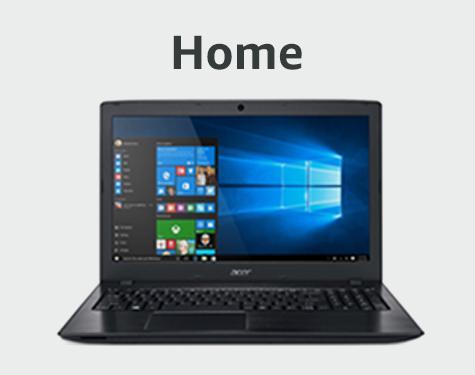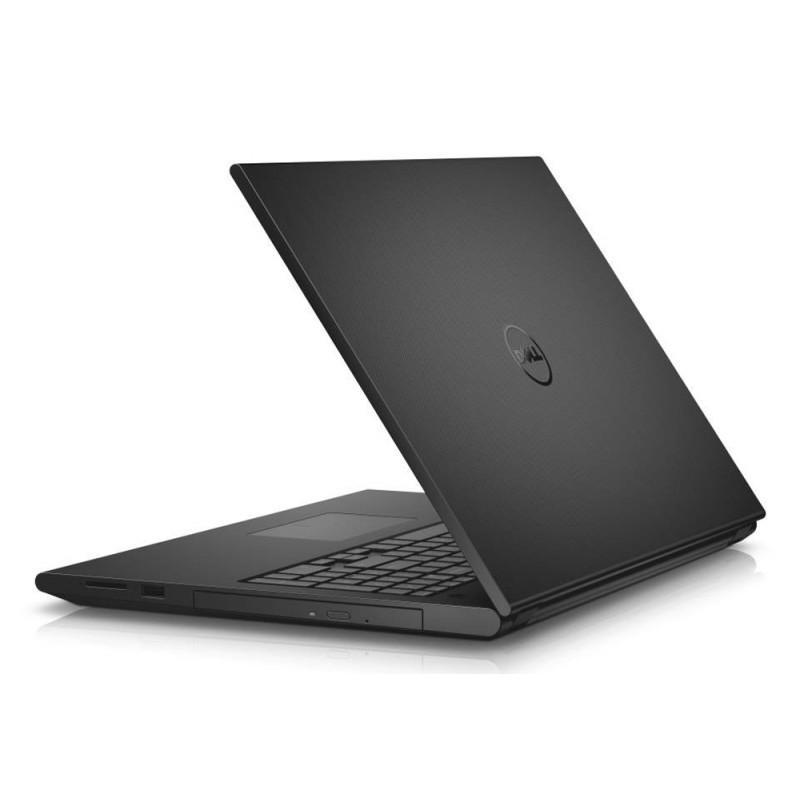The first image is the image on the left, the second image is the image on the right. Examine the images to the left and right. Is the description "The lids of all laptop computers are fully upright." accurate? Answer yes or no. No. The first image is the image on the left, the second image is the image on the right. Evaluate the accuracy of this statement regarding the images: "There are five laptops". Is it true? Answer yes or no. No. 